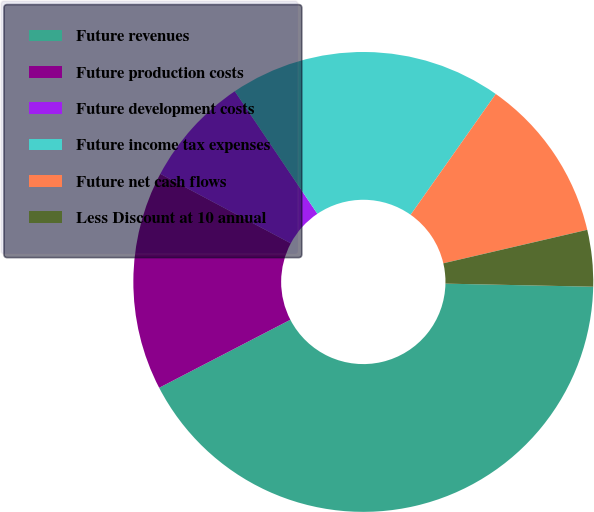Convert chart. <chart><loc_0><loc_0><loc_500><loc_500><pie_chart><fcel>Future revenues<fcel>Future production costs<fcel>Future development costs<fcel>Future income tax expenses<fcel>Future net cash flows<fcel>Less Discount at 10 annual<nl><fcel>42.06%<fcel>15.4%<fcel>7.78%<fcel>19.21%<fcel>11.59%<fcel>3.97%<nl></chart> 